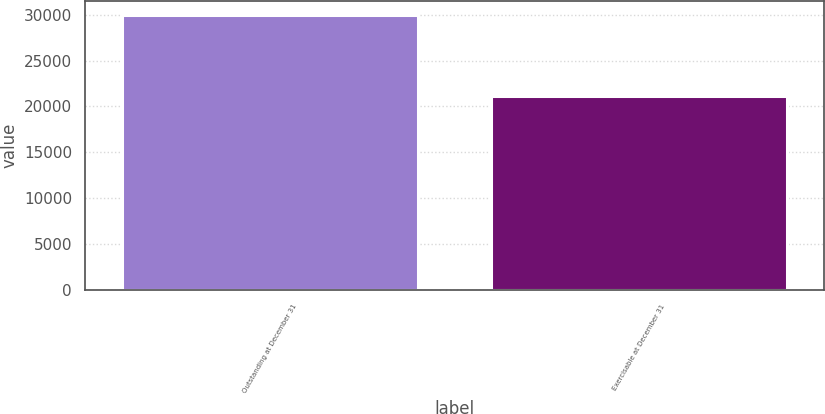<chart> <loc_0><loc_0><loc_500><loc_500><bar_chart><fcel>Outstanding at December 31<fcel>Exercisable at December 31<nl><fcel>29950<fcel>21125<nl></chart> 